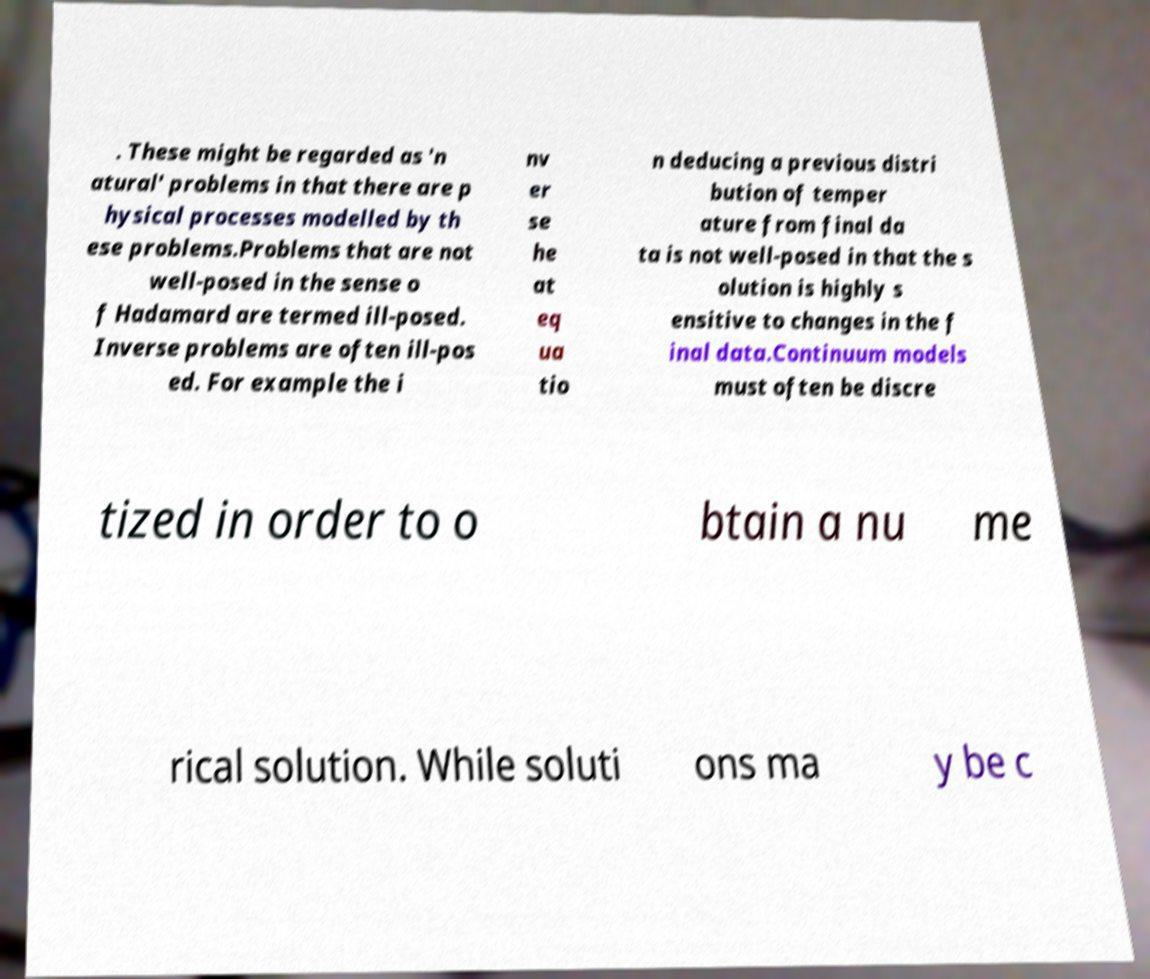There's text embedded in this image that I need extracted. Can you transcribe it verbatim? . These might be regarded as 'n atural' problems in that there are p hysical processes modelled by th ese problems.Problems that are not well-posed in the sense o f Hadamard are termed ill-posed. Inverse problems are often ill-pos ed. For example the i nv er se he at eq ua tio n deducing a previous distri bution of temper ature from final da ta is not well-posed in that the s olution is highly s ensitive to changes in the f inal data.Continuum models must often be discre tized in order to o btain a nu me rical solution. While soluti ons ma y be c 